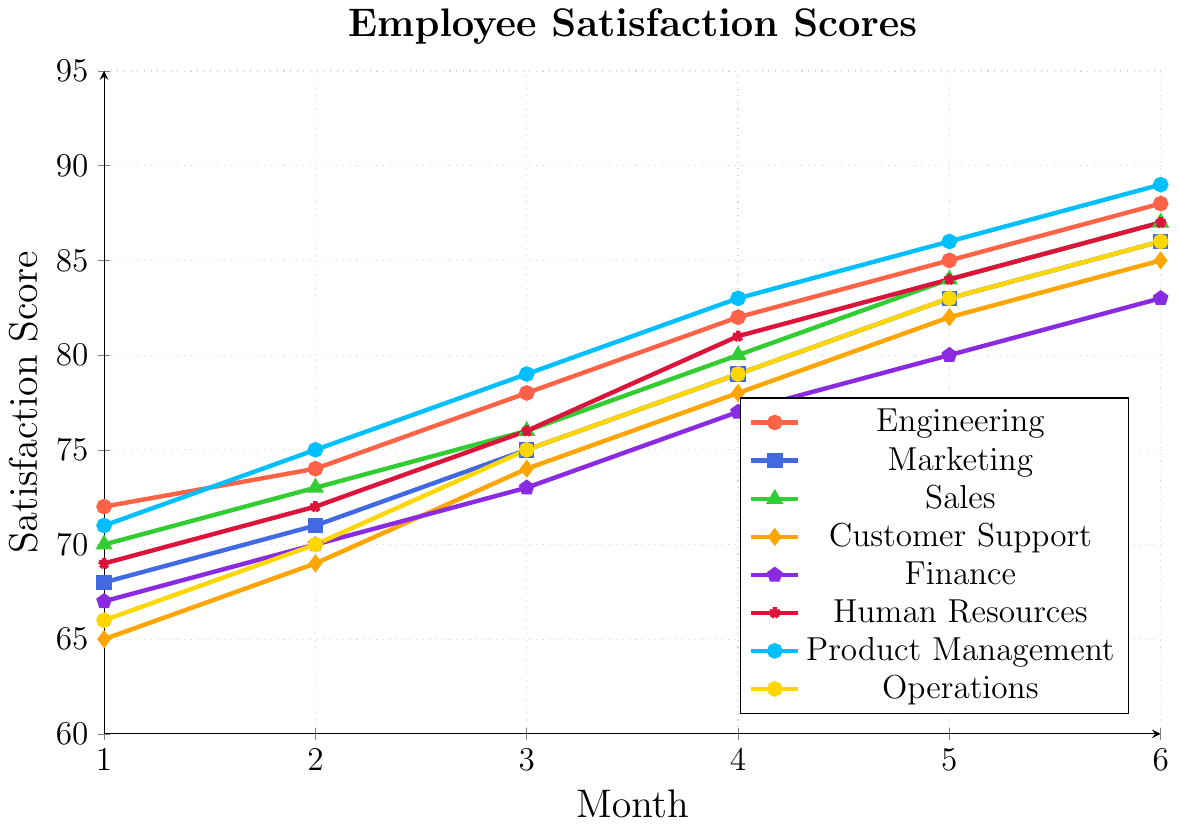What is the average satisfaction score of the Engineering department over the six months? Add the scores for Engineering department: 72+74+78+82+85+88 = 479. Divide the total by 6 to get the average: 479/6 = 79.83
Answer: 79.83 Which department had the highest satisfaction score in Month 3? Look for the highest point on the Month 3 x-axis: Engineering has 78, Marketing has 75, Sales has 76, Customer Support has 74, Finance has 73, Human Resources has 76, Product Management has 79, Operations has 75. The highest score is 79 in Product Management.
Answer: Product Management How much did the satisfaction score for Customer Support increase from Month 1 to Month 4? The score for Customer Support in Month 1 is 65 and in Month 4 is 78. Subtract Month 1 score from Month 4 score: 78 - 65 = 13
Answer: 13 Which department showed an equal satisfaction score in Month 5 as Human Resources? Human Resources has a score of 84 in Month 5. Check other departments for the same score in Month 5: Engineering has 85, Marketing has 83, Sales has 84, Customer Support has 82, Finance has 80, Product Management has 86, and Operations has 83. Sales is the department with the score of 84.
Answer: Sales What is the total increase in satisfaction score for the Operations department from Month 2 to Month 6? The score for Operations is 70 in Month 2 and 86 in Month 6. Calculate the increase: 86 - 70 = 16
Answer: 16 In which month did the Human Resources' satisfaction score surpass 80 for the first time? Check the scores for Human Resources: Month 1 (69), Month 2 (72), Month 3 (76), Month 4 (81), Month 5 (84), Month 6 (87). Human Resources' score first surpasses 80 in Month 4.
Answer: Month 4 What is the range of satisfaction scores in the Marketing department over the six months? Subtract the lowest score in Marketing from the highest: Highest score is 86 in Month 6, lowest is 68 in Month 1. Range = 86 - 68 = 18
Answer: 18 Between which months did the Finance department's satisfaction score increase the most? Compare increases month by month for Finance: Month 1 to 2 (3), Month 2 to 3 (3), Month 3 to 4 (4), Month 4 to 5 (3), Month 5 to 6 (3). The largest increase is between Month 3 and Month 4 (4 points).
Answer: Month 3 to Month 4 Which department had the lowest satisfaction score in Month 6? Refer to the satisfaction scores in Month 6: Engineering (88), Marketing (86), Sales (87), Customer Support (85), Finance (83), Human Resources (87), Product Management (89), Operations (86). The lowest score is 83 in Finance.
Answer: Finance 